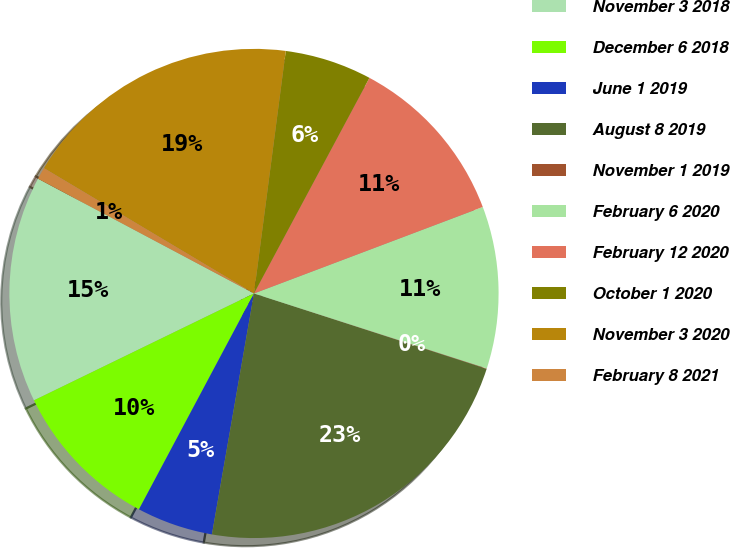Convert chart to OTSL. <chart><loc_0><loc_0><loc_500><loc_500><pie_chart><fcel>November 3 2018<fcel>December 6 2018<fcel>June 1 2019<fcel>August 8 2019<fcel>November 1 2019<fcel>February 6 2020<fcel>February 12 2020<fcel>October 1 2020<fcel>November 3 2020<fcel>February 8 2021<nl><fcel>14.97%<fcel>10.01%<fcel>5.04%<fcel>22.76%<fcel>0.03%<fcel>10.71%<fcel>11.42%<fcel>5.75%<fcel>18.51%<fcel>0.79%<nl></chart> 